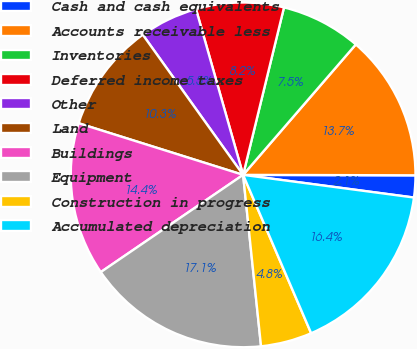Convert chart. <chart><loc_0><loc_0><loc_500><loc_500><pie_chart><fcel>Cash and cash equivalents<fcel>Accounts receivable less<fcel>Inventories<fcel>Deferred income taxes<fcel>Other<fcel>Land<fcel>Buildings<fcel>Equipment<fcel>Construction in progress<fcel>Accumulated depreciation<nl><fcel>2.06%<fcel>13.7%<fcel>7.53%<fcel>8.22%<fcel>5.48%<fcel>10.27%<fcel>14.38%<fcel>17.12%<fcel>4.8%<fcel>16.44%<nl></chart> 